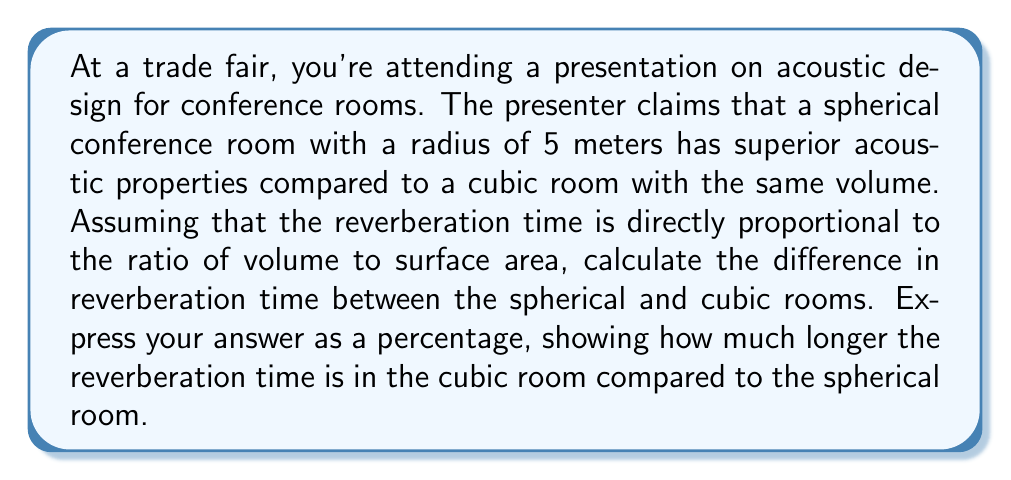Can you solve this math problem? Let's approach this step-by-step:

1) First, we need to calculate the volume of the spherical room:
   $$V_{sphere} = \frac{4}{3}\pi r^3 = \frac{4}{3}\pi \cdot 5^3 = \frac{500\pi}{3} \approx 523.6 \text{ m}^3$$

2) Since the cubic room has the same volume, we can find its side length:
   $$V_{cube} = a^3 = \frac{500\pi}{3}$$
   $$a = \sqrt[3]{\frac{500\pi}{3}} \approx 8.06 \text{ m}$$

3) Now, let's calculate the surface areas:
   For the sphere: $$A_{sphere} = 4\pi r^2 = 4\pi \cdot 5^2 = 100\pi \approx 314.2 \text{ m}^2$$
   For the cube: $$A_{cube} = 6a^2 = 6 \cdot (8.06)^2 \approx 389.7 \text{ m}^2$$

4) The reverberation time (T) is proportional to V/A. Let's call the proportionality constant k:
   $$T = k\frac{V}{A}$$

5) For the sphere: $$T_{sphere} = k\frac{523.6}{314.2} = 1.67k$$
   For the cube: $$T_{cube} = k\frac{523.6}{389.7} = 1.34k$$

6) To find the percentage difference:
   $$\text{Difference} = \frac{T_{cube} - T_{sphere}}{T_{sphere}} \times 100\%$$
   $$= \frac{1.34k - 1.67k}{1.67k} \times 100\% = -19.8\%$$

7) The negative value indicates that the reverberation time in the cubic room is actually shorter. To express how much longer the spherical room's reverberation time is:
   $$\frac{T_{sphere} - T_{cube}}{T_{cube}} \times 100\% = \frac{1.67k - 1.34k}{1.34k} \times 100\% = 24.6\%$$
Answer: The reverberation time in the spherical room is approximately 24.6% longer than in the cubic room with the same volume. 